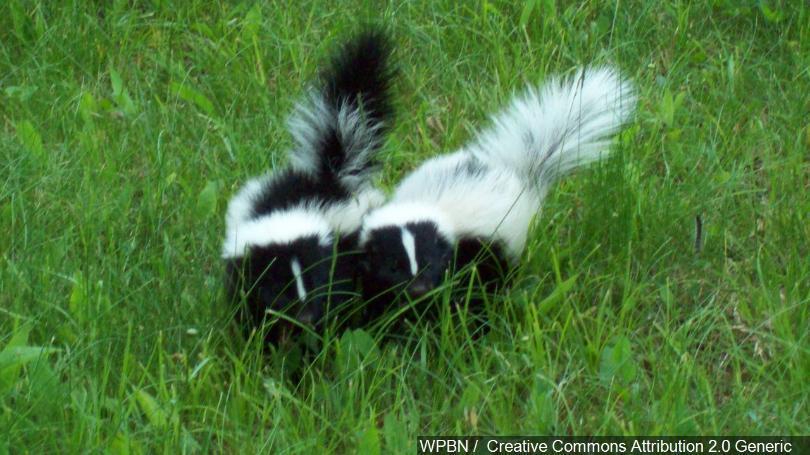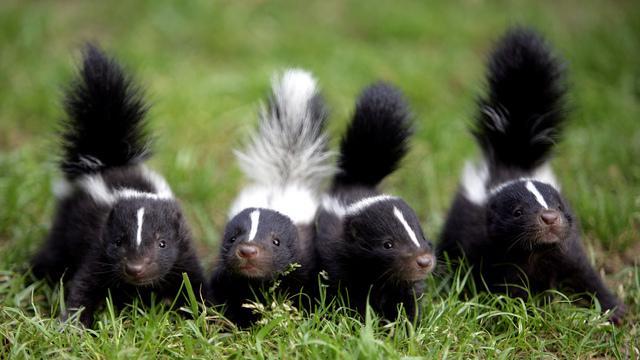The first image is the image on the left, the second image is the image on the right. For the images shown, is this caption "An image shows a forward-facing row of at least three skunks with white stripes down their faces and tails standing up." true? Answer yes or no. Yes. The first image is the image on the left, the second image is the image on the right. Evaluate the accuracy of this statement regarding the images: "At least one photo shows two or more skunks facing forward with their tails raised.". Is it true? Answer yes or no. Yes. 